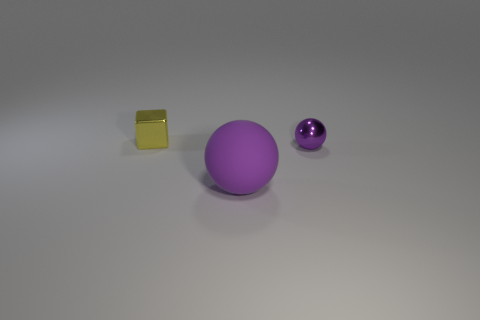Add 3 gray matte cubes. How many objects exist? 6 Add 2 small metal balls. How many small metal balls are left? 3 Add 1 shiny cubes. How many shiny cubes exist? 2 Subtract 0 gray blocks. How many objects are left? 3 Subtract all balls. How many objects are left? 1 Subtract all metallic cubes. Subtract all purple matte balls. How many objects are left? 1 